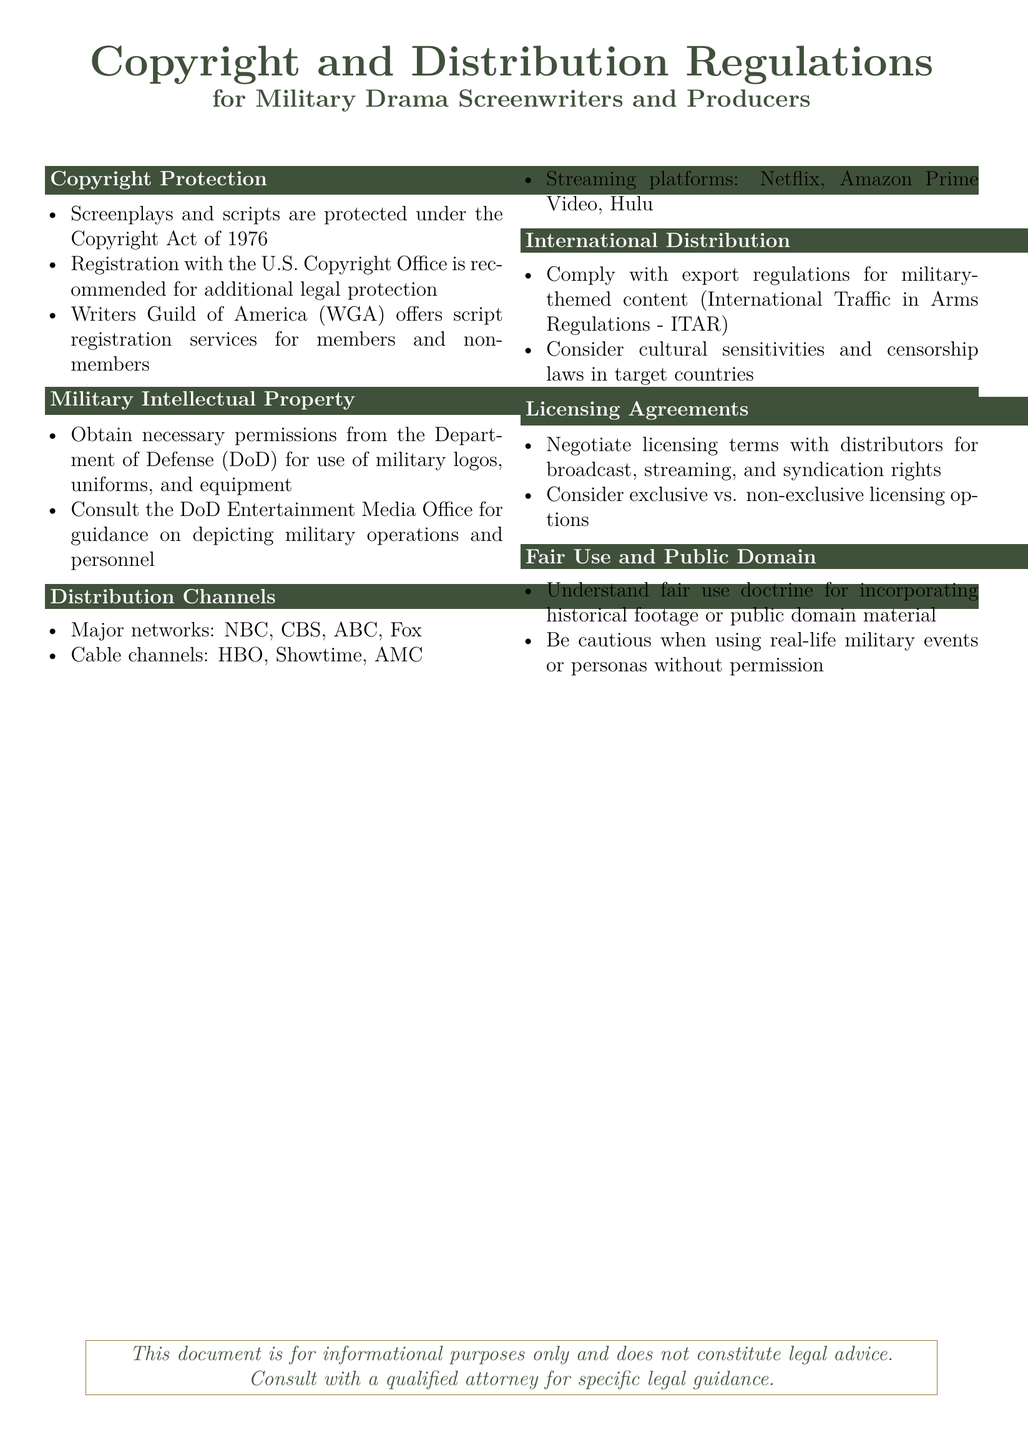What is protected under the Copyright Act of 1976? Screenplays and scripts are protected under the Copyright Act of 1976.
Answer: Screenplays and scripts What organization offers script registration services? The document states that the Writers Guild of America (WGA) offers script registration services.
Answer: Writers Guild of America What must be obtained for the use of military logos? The document mentions obtaining necessary permissions from the Department of Defense (DoD) for the use of military logos.
Answer: Department of Defense Which two types of distribution channels are mentioned? The document lists major networks, cable channels, and streaming platforms as distribution channels.
Answer: Major networks, cable channels What regulatory compliance is necessary for international distribution? The document states that compliance with the International Traffic in Arms Regulations (ITAR) is necessary for military-themed content.
Answer: International Traffic in Arms Regulations What is a key factor to consider when negotiating licensing agreements? The document suggests considering exclusive vs. non-exclusive licensing options when negotiating licensing agreements.
Answer: Exclusive vs. non-exclusive What does fair use doctrine relate to in this document? The fair use doctrine relates to incorporating historical footage or public domain material as mentioned in the document.
Answer: Incorporating historical footage What type of advice does this document not provide? The document specifies that it does not constitute legal advice.
Answer: Legal advice 